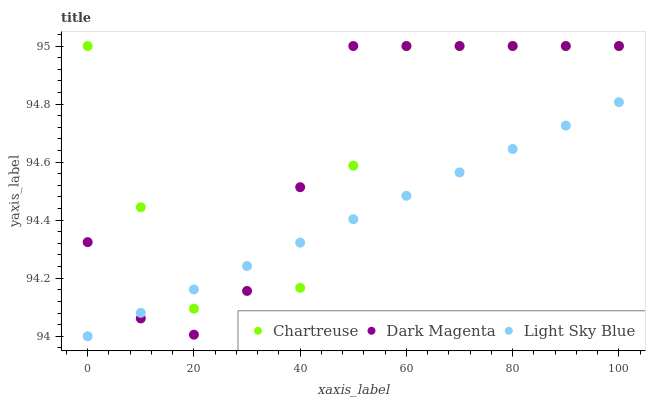Does Light Sky Blue have the minimum area under the curve?
Answer yes or no. Yes. Does Dark Magenta have the maximum area under the curve?
Answer yes or no. Yes. Does Dark Magenta have the minimum area under the curve?
Answer yes or no. No. Does Light Sky Blue have the maximum area under the curve?
Answer yes or no. No. Is Light Sky Blue the smoothest?
Answer yes or no. Yes. Is Chartreuse the roughest?
Answer yes or no. Yes. Is Dark Magenta the smoothest?
Answer yes or no. No. Is Dark Magenta the roughest?
Answer yes or no. No. Does Light Sky Blue have the lowest value?
Answer yes or no. Yes. Does Dark Magenta have the lowest value?
Answer yes or no. No. Does Dark Magenta have the highest value?
Answer yes or no. Yes. Does Light Sky Blue have the highest value?
Answer yes or no. No. Does Light Sky Blue intersect Chartreuse?
Answer yes or no. Yes. Is Light Sky Blue less than Chartreuse?
Answer yes or no. No. Is Light Sky Blue greater than Chartreuse?
Answer yes or no. No. 